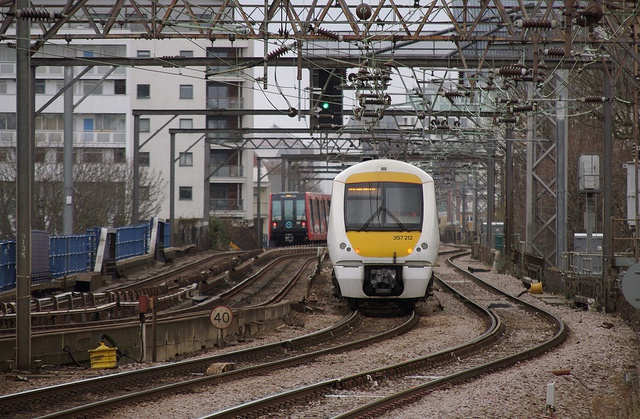Describe the objects in this image and their specific colors. I can see train in gray, darkgray, black, and lightgray tones, train in gray, black, and brown tones, and traffic light in gray, black, darkgreen, and white tones in this image. 